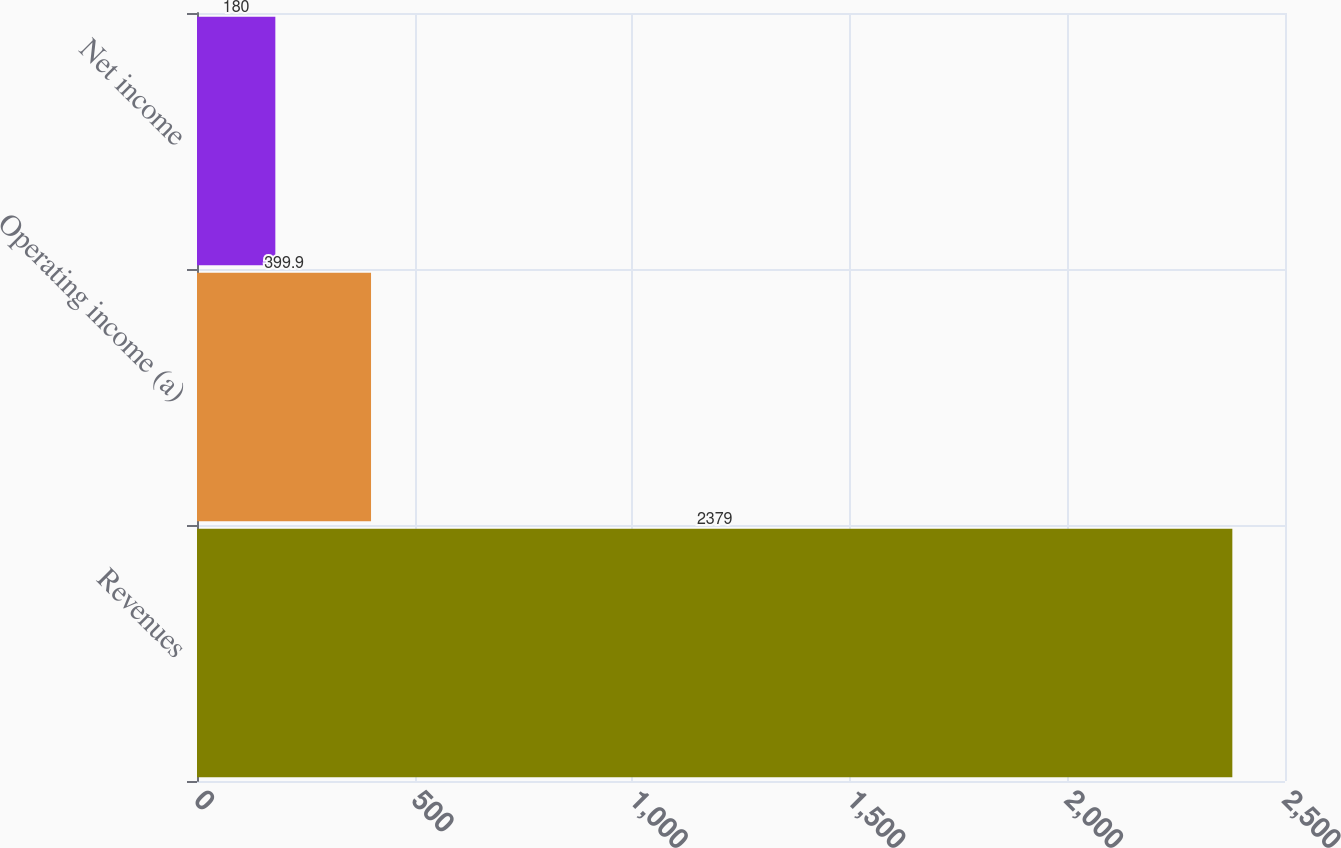<chart> <loc_0><loc_0><loc_500><loc_500><bar_chart><fcel>Revenues<fcel>Operating income (a)<fcel>Net income<nl><fcel>2379<fcel>399.9<fcel>180<nl></chart> 